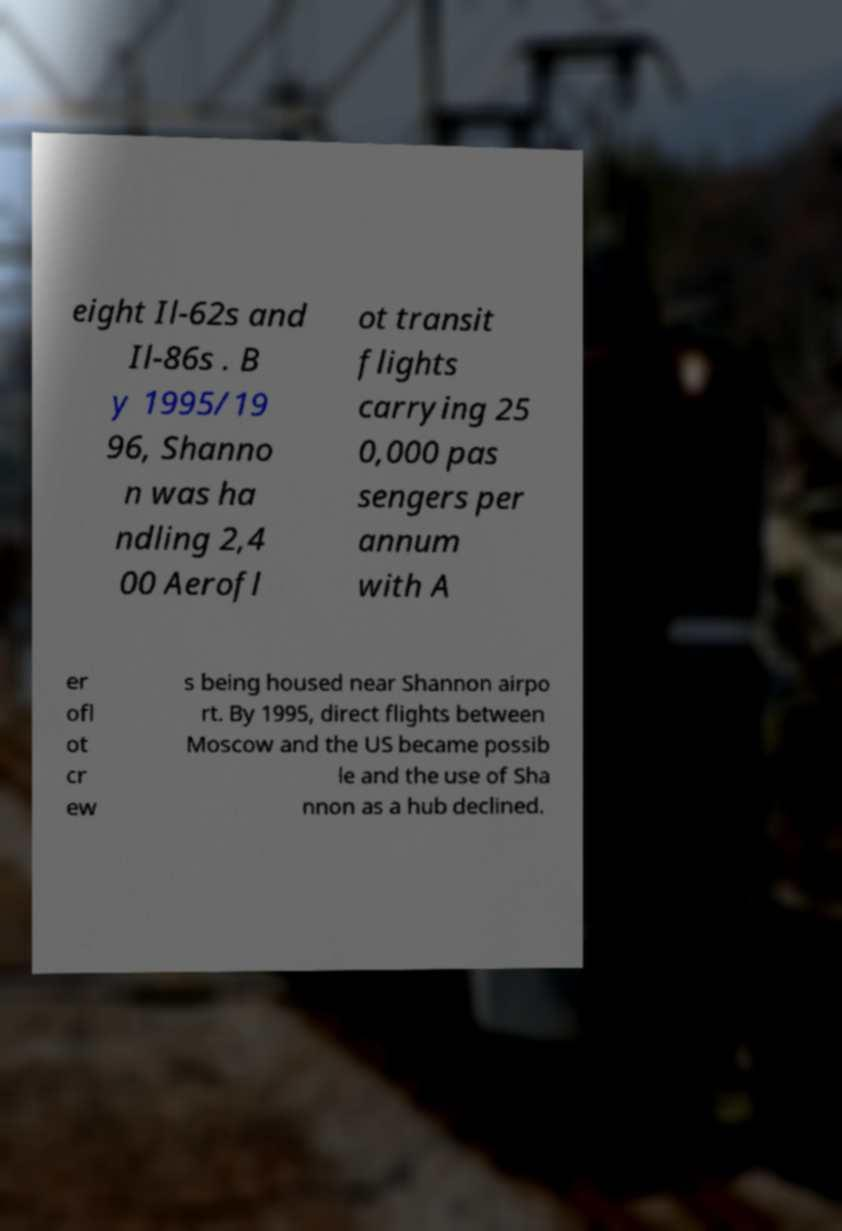For documentation purposes, I need the text within this image transcribed. Could you provide that? eight Il-62s and Il-86s . B y 1995/19 96, Shanno n was ha ndling 2,4 00 Aerofl ot transit flights carrying 25 0,000 pas sengers per annum with A er ofl ot cr ew s being housed near Shannon airpo rt. By 1995, direct flights between Moscow and the US became possib le and the use of Sha nnon as a hub declined. 